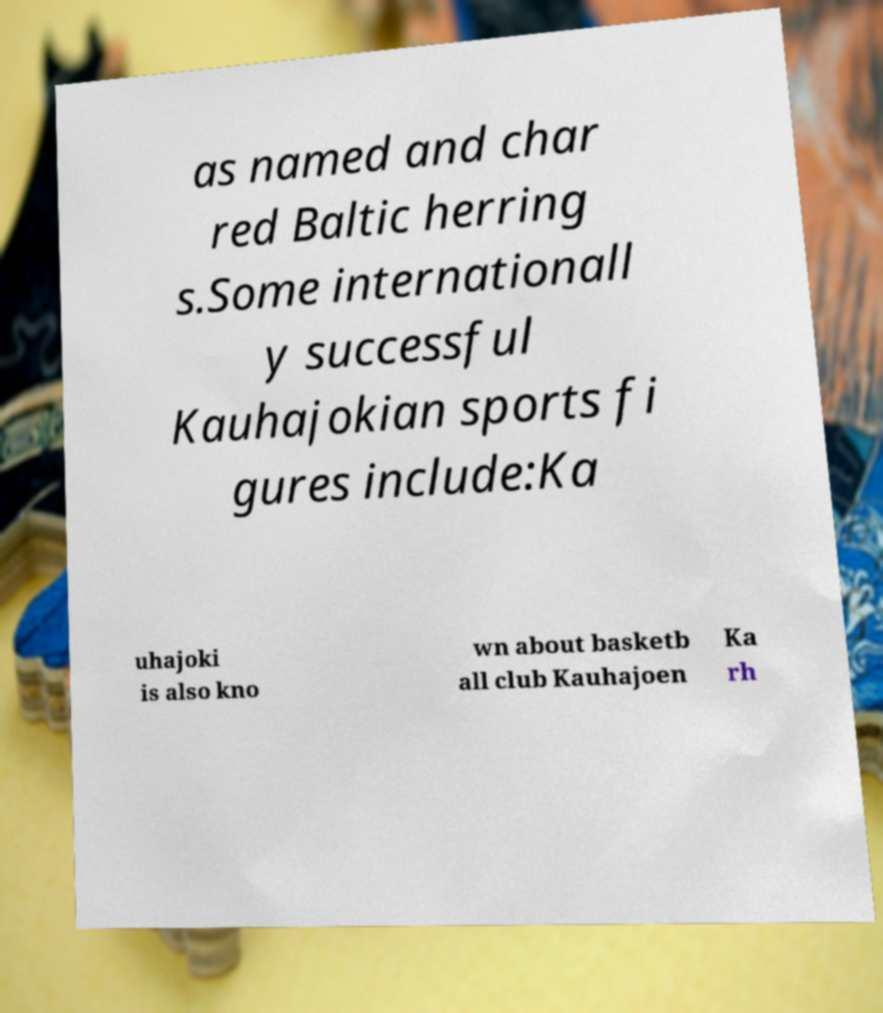Can you read and provide the text displayed in the image?This photo seems to have some interesting text. Can you extract and type it out for me? as named and char red Baltic herring s.Some internationall y successful Kauhajokian sports fi gures include:Ka uhajoki is also kno wn about basketb all club Kauhajoen Ka rh 